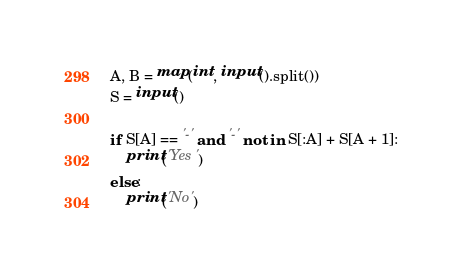<code> <loc_0><loc_0><loc_500><loc_500><_Python_>A, B = map(int, input().split())
S = input()

if S[A] == '-' and '-' not in S[:A] + S[A + 1]:
    print('Yes')
else:
    print('No')</code> 